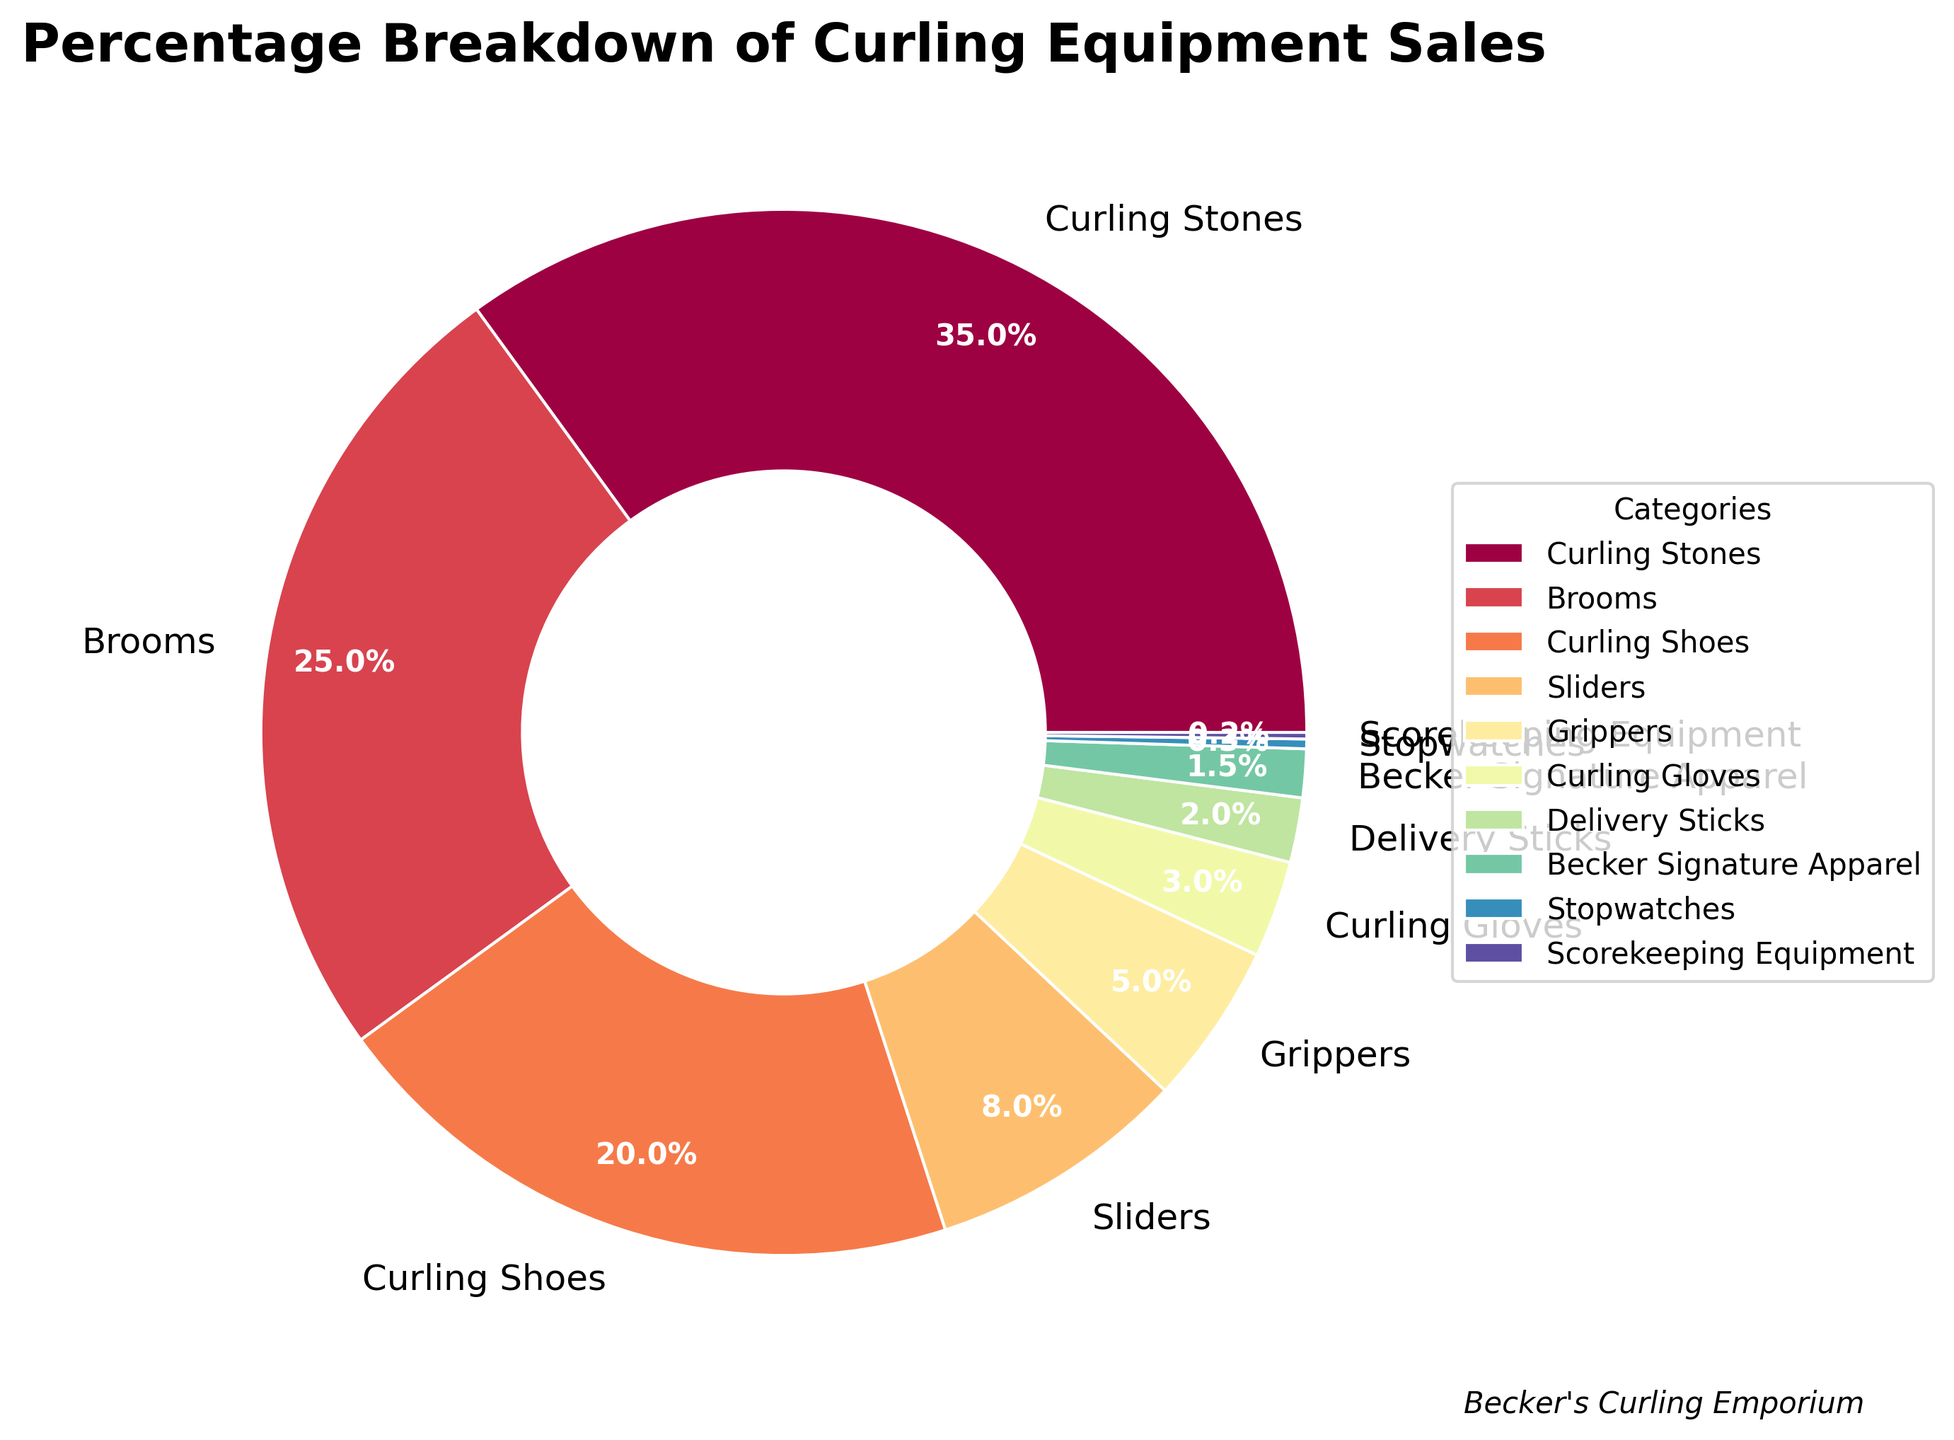Which category represents the largest percentage of sales? The figure shows a breakdown of curling equipment sales, where Curling Stones segment has the largest slice of the pie chart, represented by 35%.
Answer: Curling Stones Which categories combined account for over half of the sales? Adding the percentages of Curling Stones (35%) and Brooms (25%) results in 60%. This combination exceeds 50%.
Answer: Curling Stones and Brooms How do the sales percentages of Sliders and Grippers compare? The percentage of Sliders sales is 8%, while the percentage of Grippers sales is 5%. Since 8% is greater than 5%, Sliders have a higher sales percentage than Grippers.
Answer: Sliders > Grippers What is the combined sales percentage of the categories with less than 5% each? Adding the percentages of Grippers (5%), Curling Gloves (3%), Delivery Sticks (2%), Becker Signature Apparel (1.5%), Stopwatches (0.3%), and Scorekeeping Equipment (0.2%) results in 12%.
Answer: 12% How does the sales percentage of Curling Shoes compare to Curling Stones? The sales percentage for Curling Shoes is 20%, while for Curling Stones it is 35%. Since 20% is less than 35%, Curling Shoes has a lower sales percentage than Curling Stones.
Answer: Curling Shoes < Curling Stones Which category has the smallest percentage of sales? The smallest segment in the pie chart represents Scorekeeping Equipment, with a percentage of 0.2%.
Answer: Scorekeeping Equipment How much more percentage do Brooms account for than Curling Gloves? The sales percentage for Brooms is 25%, and for Curling Gloves, it is 3%. The difference is 25% - 3% = 22%.
Answer: 22% Which category associated with Peter Becker has the smallest percentage? Observing the chart, Becker Signature Apparel accounts for 1.5% of the sales. This is the only category associated with Peter Becker and also has a small percentage.
Answer: Becker Signature Apparel What is the combined percentage of Curling Shoes and Brooms? Adding the percentages of Curling Shoes (20%) and Brooms (25%) gives 45%.
Answer: 45% Which segment is represented with a color close to the end of the color spectrum visible in the chart? Becker Signature Apparel is represented with a color close to purple, which is near the end of the visible color spectrum in the chart.
Answer: Becker Signature Apparel 